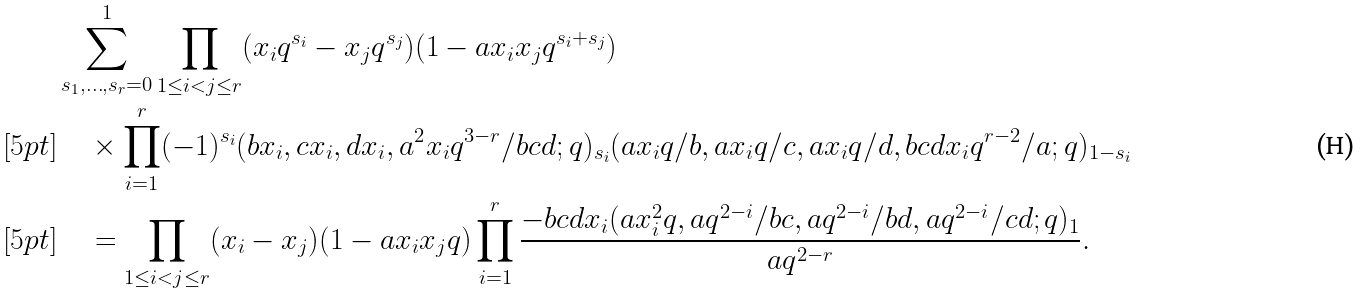<formula> <loc_0><loc_0><loc_500><loc_500>& \sum _ { s _ { 1 } , \dots , s _ { r } = 0 } ^ { 1 } \prod _ { 1 \leq i < j \leq r } ( x _ { i } q ^ { s _ { i } } - x _ { j } q ^ { s _ { j } } ) ( 1 - a x _ { i } x _ { j } q ^ { s _ { i } + s _ { j } } ) \\ [ 5 p t ] & \quad \times \prod _ { i = 1 } ^ { r } ( - 1 ) ^ { s _ { i } } ( b x _ { i } , c x _ { i } , d x _ { i } , a ^ { 2 } x _ { i } q ^ { 3 - r } / b c d ; q ) _ { s _ { i } } ( a x _ { i } q / b , a x _ { i } q / c , a x _ { i } q / d , b c d x _ { i } q ^ { r - 2 } / a ; q ) _ { 1 - s _ { i } } \\ [ 5 p t ] & \quad = \prod _ { 1 \leq i < j \leq r } ( x _ { i } - x _ { j } ) ( 1 - a x _ { i } x _ { j } q ) \prod _ { i = 1 } ^ { r } \frac { - b c d x _ { i } ( a x _ { i } ^ { 2 } q , a q ^ { 2 - i } / b c , a q ^ { 2 - i } / b d , a q ^ { 2 - i } / c d ; q ) _ { 1 } } { a q ^ { 2 - r } } .</formula> 